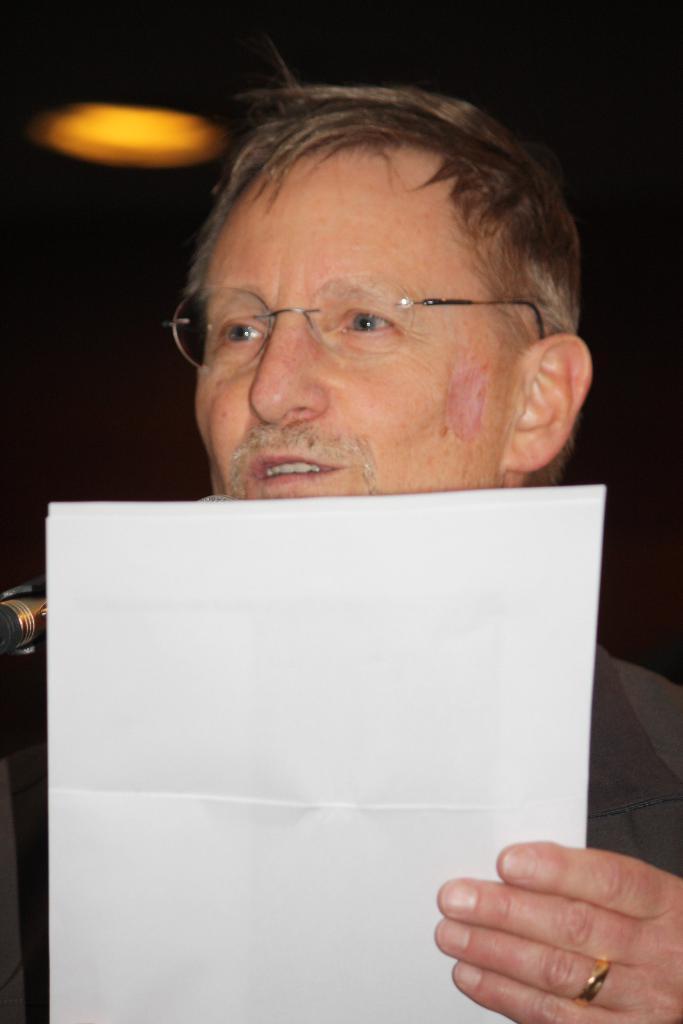Please provide a concise description of this image. In this image I can see a person holding papers. Back I can see a yellow light and black background. 